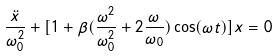Convert formula to latex. <formula><loc_0><loc_0><loc_500><loc_500>\frac { \ddot { x } } { \omega _ { 0 } ^ { 2 } } + [ 1 + \beta ( \frac { \omega ^ { 2 } } { \omega _ { 0 } ^ { 2 } } + 2 \frac { \omega } { \omega _ { 0 } } ) \cos ( \omega t ) ] x = 0</formula> 